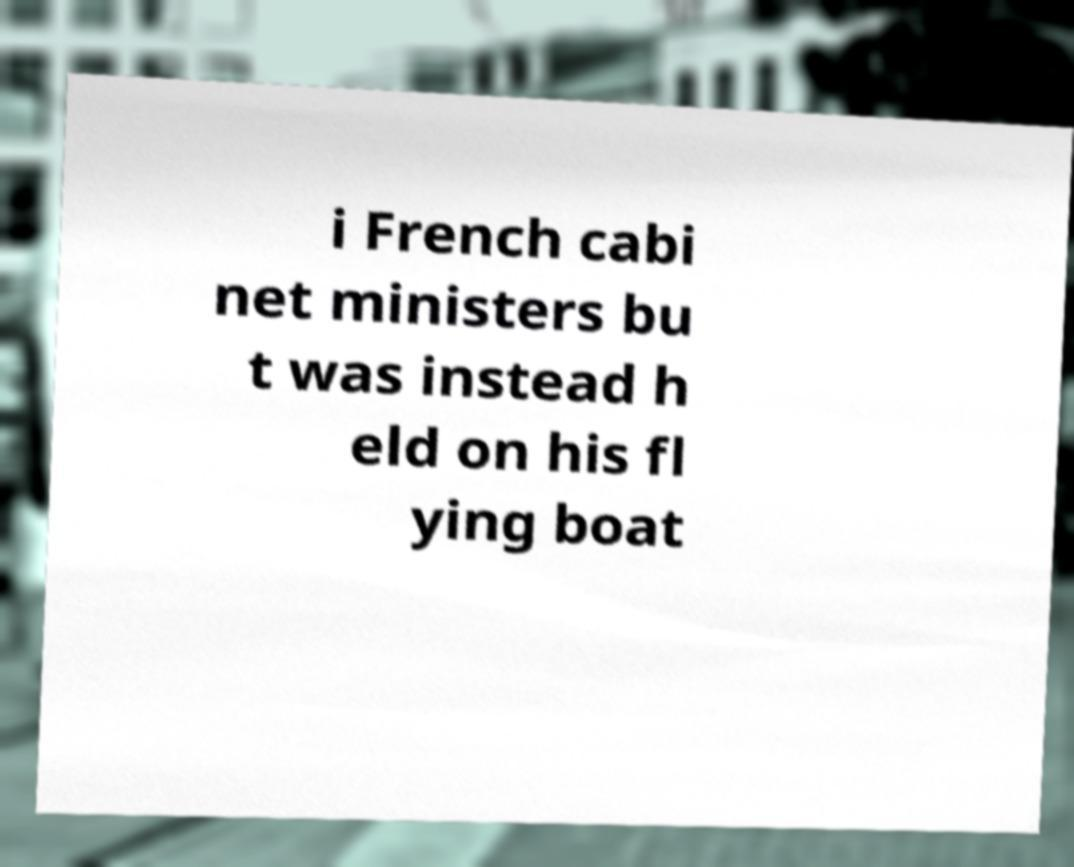Could you assist in decoding the text presented in this image and type it out clearly? i French cabi net ministers bu t was instead h eld on his fl ying boat 